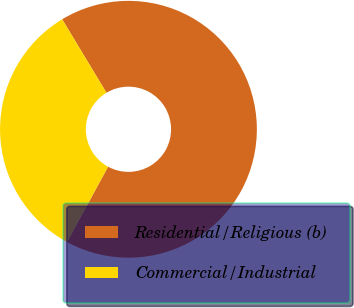Convert chart. <chart><loc_0><loc_0><loc_500><loc_500><pie_chart><fcel>Residential/Religious (b)<fcel>Commercial/Industrial<nl><fcel>66.57%<fcel>33.43%<nl></chart> 